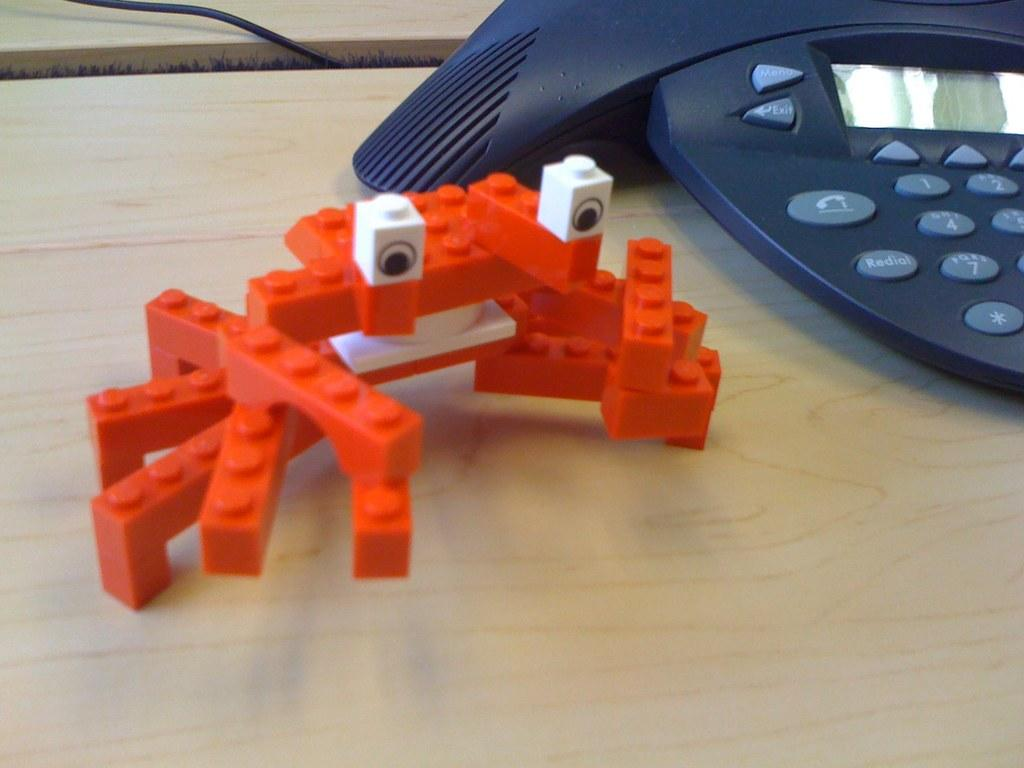Provide a one-sentence caption for the provided image. An orange lego crab on a wooden table next to a conference phone with the buttons exit and menu. 